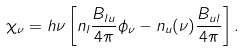Convert formula to latex. <formula><loc_0><loc_0><loc_500><loc_500>\chi _ { \nu } = h \nu \left [ n _ { l } \frac { B _ { l u } } { 4 \pi } \phi _ { \nu } - n _ { u } ( \nu ) \frac { B _ { u l } } { 4 \pi } \right ] .</formula> 